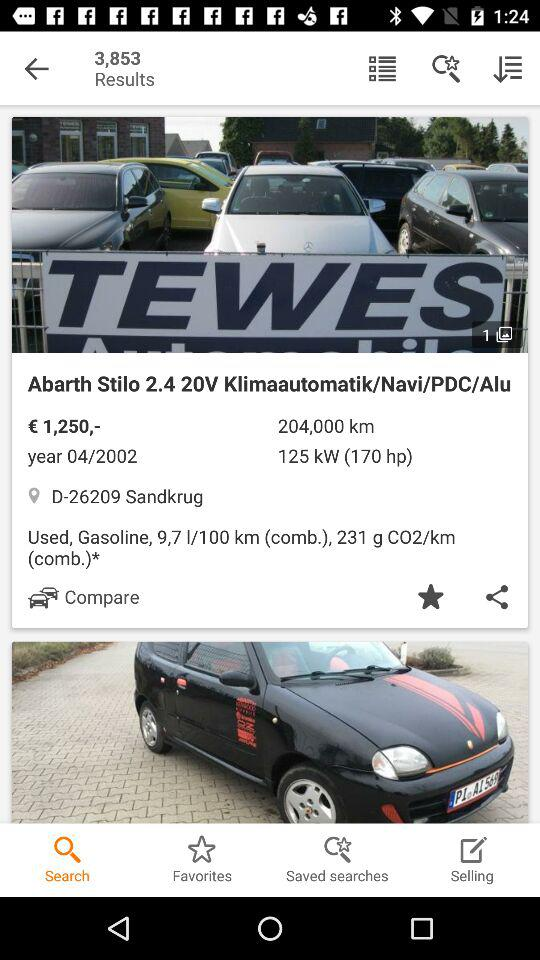How much horsepower does the engine have? The engine has 170 horsepower. 